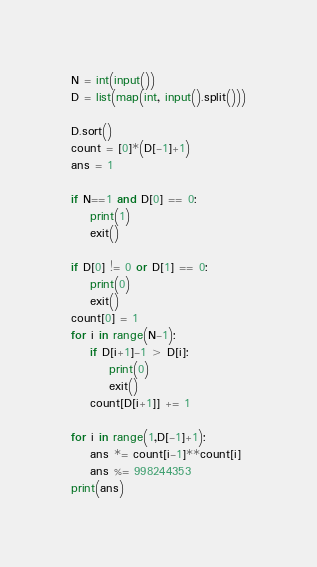<code> <loc_0><loc_0><loc_500><loc_500><_Python_>N = int(input())
D = list(map(int, input().split()))

D.sort()
count = [0]*(D[-1]+1)
ans = 1

if N==1 and D[0] == 0:
    print(1)
    exit()

if D[0] != 0 or D[1] == 0:
    print(0)
    exit()
count[0] = 1
for i in range(N-1):
    if D[i+1]-1 > D[i]:
        print(0)
        exit()
    count[D[i+1]] += 1

for i in range(1,D[-1]+1):
    ans *= count[i-1]**count[i]
    ans %= 998244353
print(ans)
</code> 